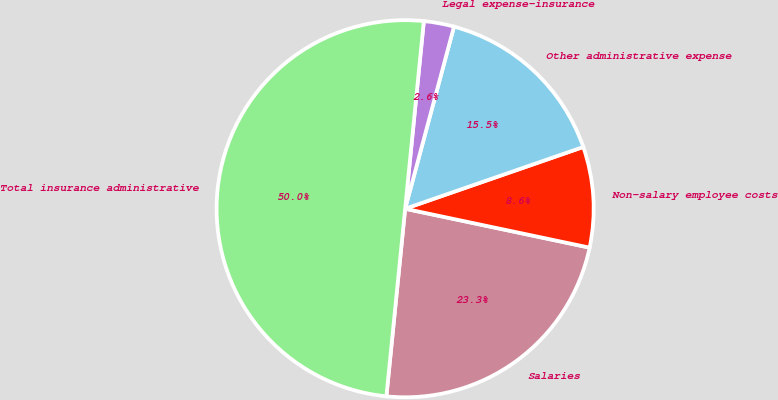<chart> <loc_0><loc_0><loc_500><loc_500><pie_chart><fcel>Salaries<fcel>Non-salary employee costs<fcel>Other administrative expense<fcel>Legal expense-insurance<fcel>Total insurance administrative<nl><fcel>23.28%<fcel>8.62%<fcel>15.52%<fcel>2.59%<fcel>50.0%<nl></chart> 